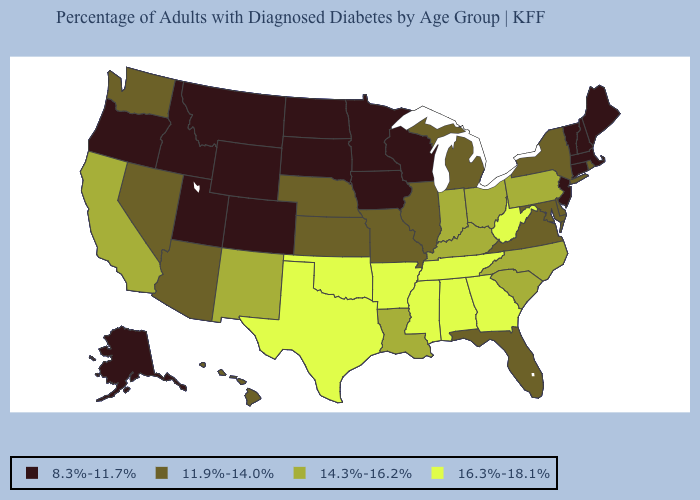Among the states that border Rhode Island , which have the highest value?
Quick response, please. Connecticut, Massachusetts. Does Connecticut have the same value as Massachusetts?
Concise answer only. Yes. Among the states that border West Virginia , which have the lowest value?
Answer briefly. Maryland, Virginia. Does Kansas have the lowest value in the MidWest?
Write a very short answer. No. Name the states that have a value in the range 14.3%-16.2%?
Write a very short answer. California, Indiana, Kentucky, Louisiana, New Mexico, North Carolina, Ohio, Pennsylvania, South Carolina. Does Indiana have the highest value in the MidWest?
Be succinct. Yes. Does Alabama have the highest value in the USA?
Concise answer only. Yes. Name the states that have a value in the range 11.9%-14.0%?
Concise answer only. Arizona, Delaware, Florida, Hawaii, Illinois, Kansas, Maryland, Michigan, Missouri, Nebraska, Nevada, New York, Rhode Island, Virginia, Washington. Among the states that border Minnesota , which have the lowest value?
Keep it brief. Iowa, North Dakota, South Dakota, Wisconsin. Is the legend a continuous bar?
Quick response, please. No. Does Texas have the highest value in the USA?
Concise answer only. Yes. What is the lowest value in states that border Mississippi?
Short answer required. 14.3%-16.2%. Which states have the lowest value in the USA?
Give a very brief answer. Alaska, Colorado, Connecticut, Idaho, Iowa, Maine, Massachusetts, Minnesota, Montana, New Hampshire, New Jersey, North Dakota, Oregon, South Dakota, Utah, Vermont, Wisconsin, Wyoming. Name the states that have a value in the range 11.9%-14.0%?
Give a very brief answer. Arizona, Delaware, Florida, Hawaii, Illinois, Kansas, Maryland, Michigan, Missouri, Nebraska, Nevada, New York, Rhode Island, Virginia, Washington. 